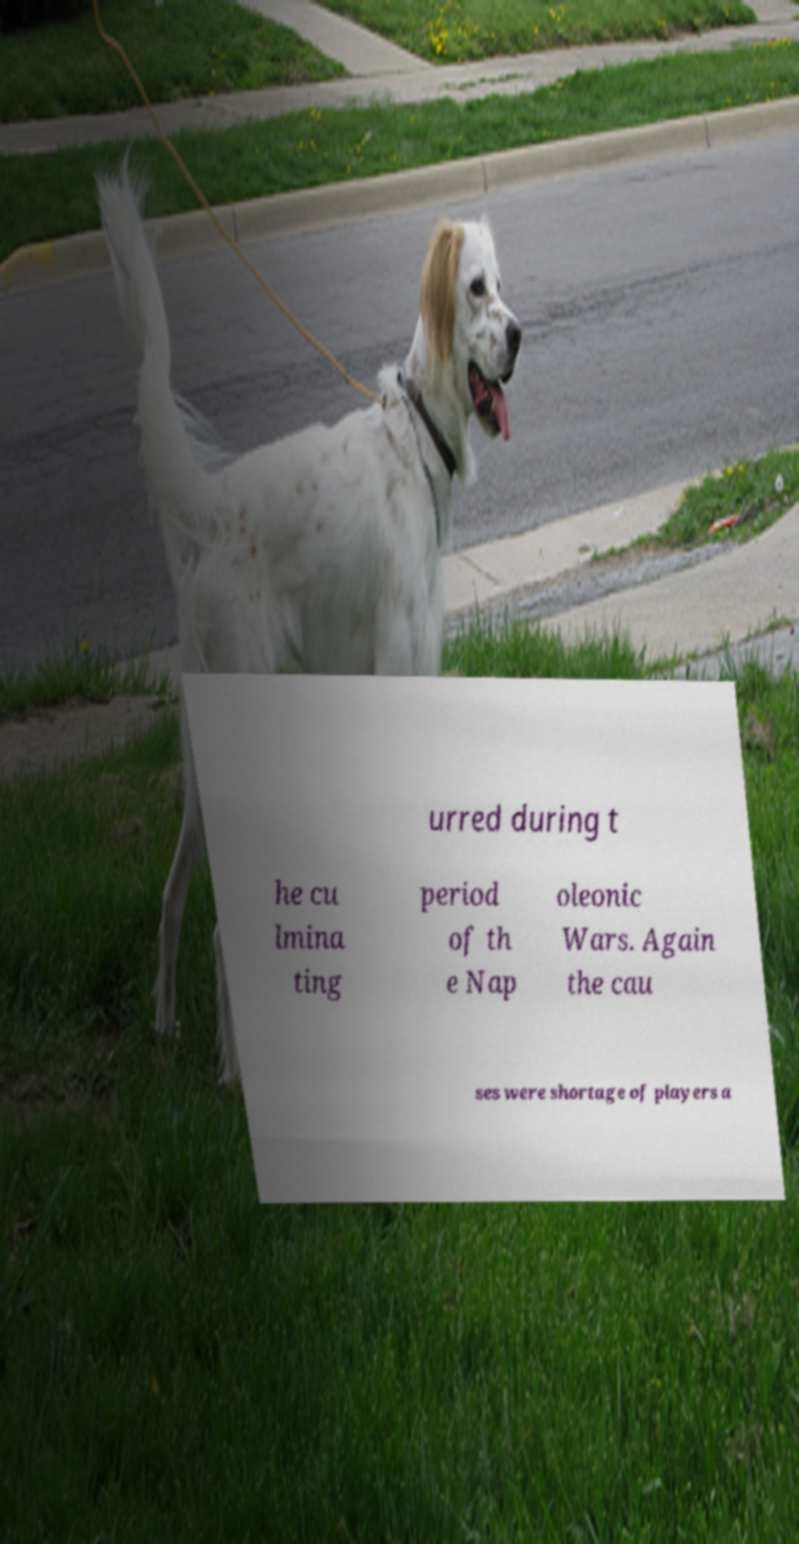Please read and relay the text visible in this image. What does it say? urred during t he cu lmina ting period of th e Nap oleonic Wars. Again the cau ses were shortage of players a 